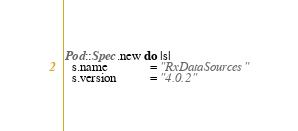<code> <loc_0><loc_0><loc_500><loc_500><_Ruby_>Pod::Spec.new do |s|
  s.name             = "RxDataSources"
  s.version          = "4.0.2"</code> 